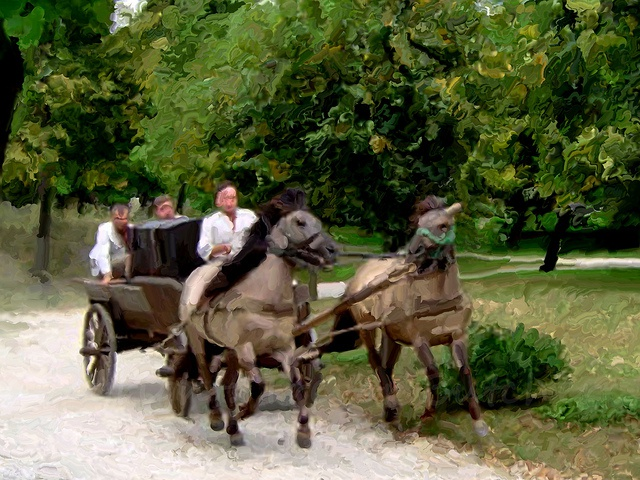Describe the objects in this image and their specific colors. I can see horse in darkgreen, black, gray, and maroon tones, horse in darkgreen, black, maroon, and gray tones, people in darkgreen, lightgray, darkgray, black, and gray tones, people in darkgreen, lavender, gray, and darkgray tones, and people in darkgreen, brown, and salmon tones in this image. 